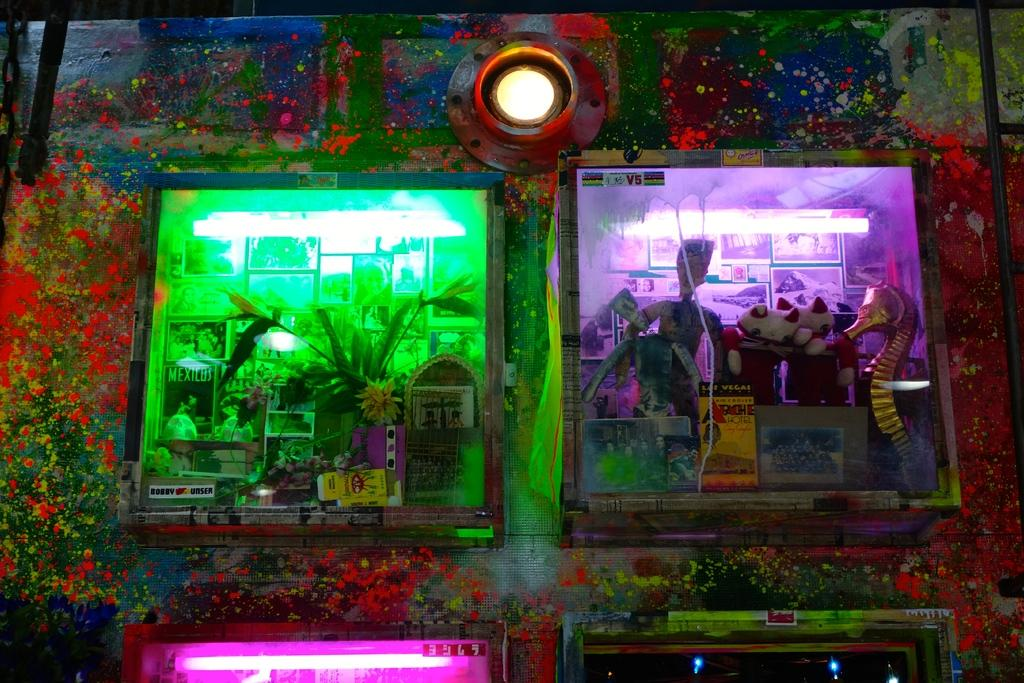What object is the main focus of the image? There is a toy camera in the image. What feature of the toy camera is highlighted in the image? The toy camera contains different images. What type of texture can be seen on the toe of the person in the image? There is no person present in the image, only a toy camera with different images. 